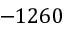<formula> <loc_0><loc_0><loc_500><loc_500>- 1 2 6 0</formula> 